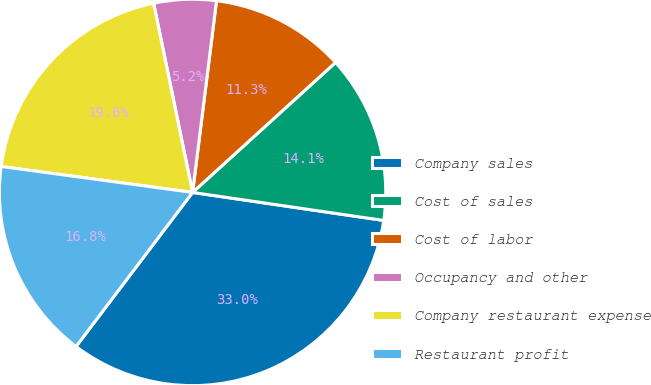Convert chart to OTSL. <chart><loc_0><loc_0><loc_500><loc_500><pie_chart><fcel>Company sales<fcel>Cost of sales<fcel>Cost of labor<fcel>Occupancy and other<fcel>Company restaurant expense<fcel>Restaurant profit<nl><fcel>32.99%<fcel>14.06%<fcel>11.28%<fcel>5.21%<fcel>19.62%<fcel>16.84%<nl></chart> 